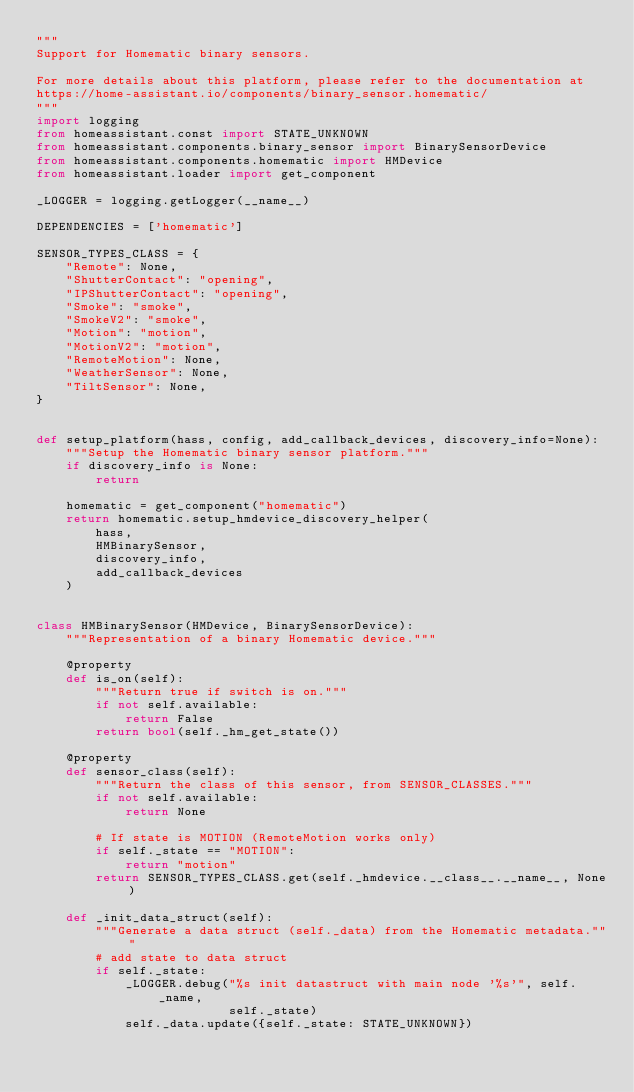Convert code to text. <code><loc_0><loc_0><loc_500><loc_500><_Python_>"""
Support for Homematic binary sensors.

For more details about this platform, please refer to the documentation at
https://home-assistant.io/components/binary_sensor.homematic/
"""
import logging
from homeassistant.const import STATE_UNKNOWN
from homeassistant.components.binary_sensor import BinarySensorDevice
from homeassistant.components.homematic import HMDevice
from homeassistant.loader import get_component

_LOGGER = logging.getLogger(__name__)

DEPENDENCIES = ['homematic']

SENSOR_TYPES_CLASS = {
    "Remote": None,
    "ShutterContact": "opening",
    "IPShutterContact": "opening",
    "Smoke": "smoke",
    "SmokeV2": "smoke",
    "Motion": "motion",
    "MotionV2": "motion",
    "RemoteMotion": None,
    "WeatherSensor": None,
    "TiltSensor": None,
}


def setup_platform(hass, config, add_callback_devices, discovery_info=None):
    """Setup the Homematic binary sensor platform."""
    if discovery_info is None:
        return

    homematic = get_component("homematic")
    return homematic.setup_hmdevice_discovery_helper(
        hass,
        HMBinarySensor,
        discovery_info,
        add_callback_devices
    )


class HMBinarySensor(HMDevice, BinarySensorDevice):
    """Representation of a binary Homematic device."""

    @property
    def is_on(self):
        """Return true if switch is on."""
        if not self.available:
            return False
        return bool(self._hm_get_state())

    @property
    def sensor_class(self):
        """Return the class of this sensor, from SENSOR_CLASSES."""
        if not self.available:
            return None

        # If state is MOTION (RemoteMotion works only)
        if self._state == "MOTION":
            return "motion"
        return SENSOR_TYPES_CLASS.get(self._hmdevice.__class__.__name__, None)

    def _init_data_struct(self):
        """Generate a data struct (self._data) from the Homematic metadata."""
        # add state to data struct
        if self._state:
            _LOGGER.debug("%s init datastruct with main node '%s'", self._name,
                          self._state)
            self._data.update({self._state: STATE_UNKNOWN})
</code> 